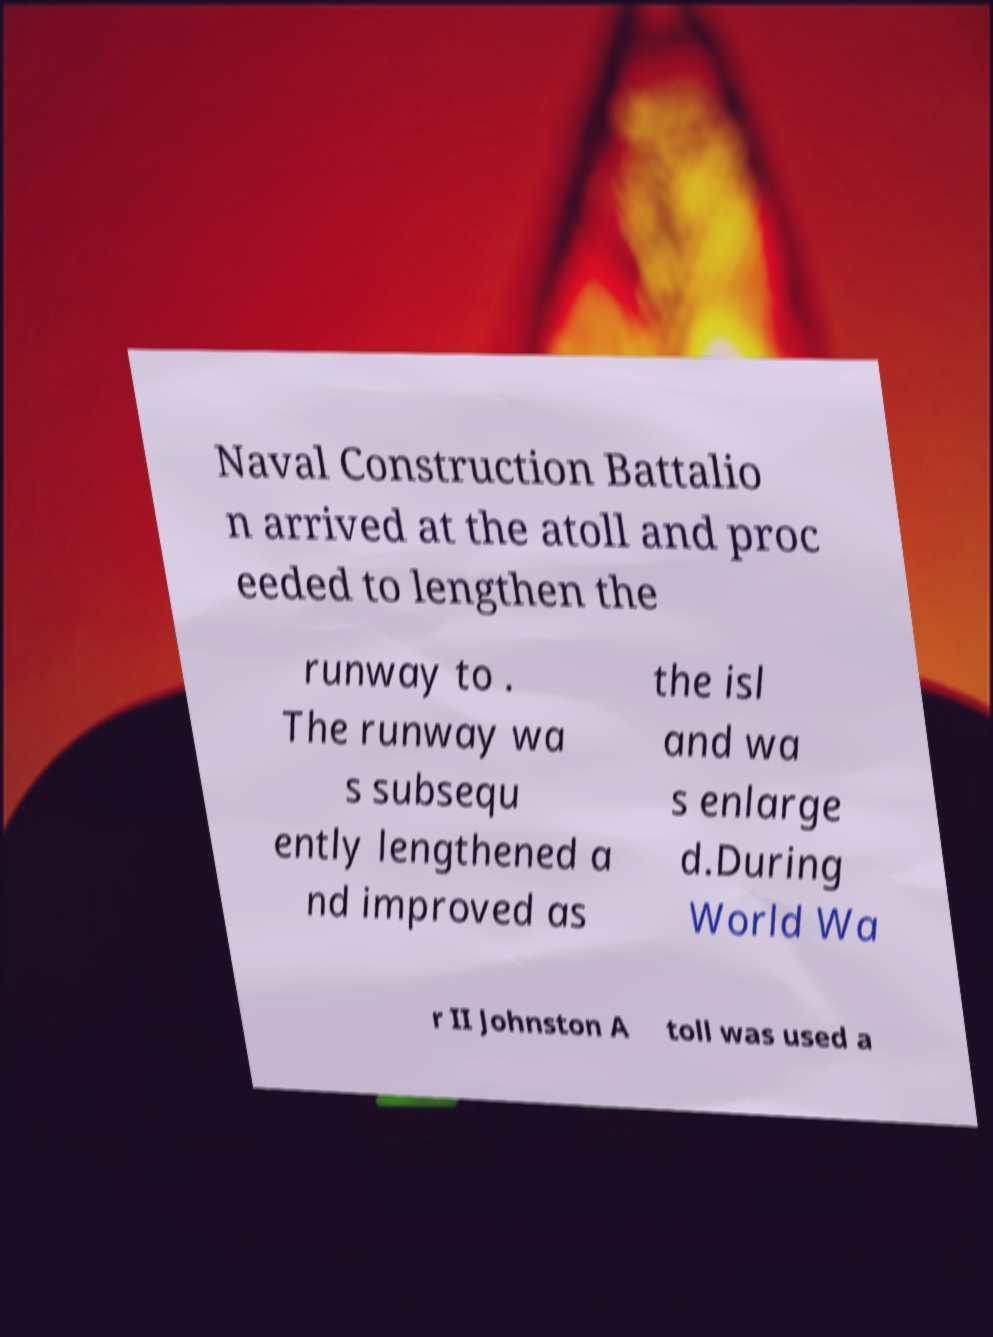I need the written content from this picture converted into text. Can you do that? Naval Construction Battalio n arrived at the atoll and proc eeded to lengthen the runway to . The runway wa s subsequ ently lengthened a nd improved as the isl and wa s enlarge d.During World Wa r II Johnston A toll was used a 